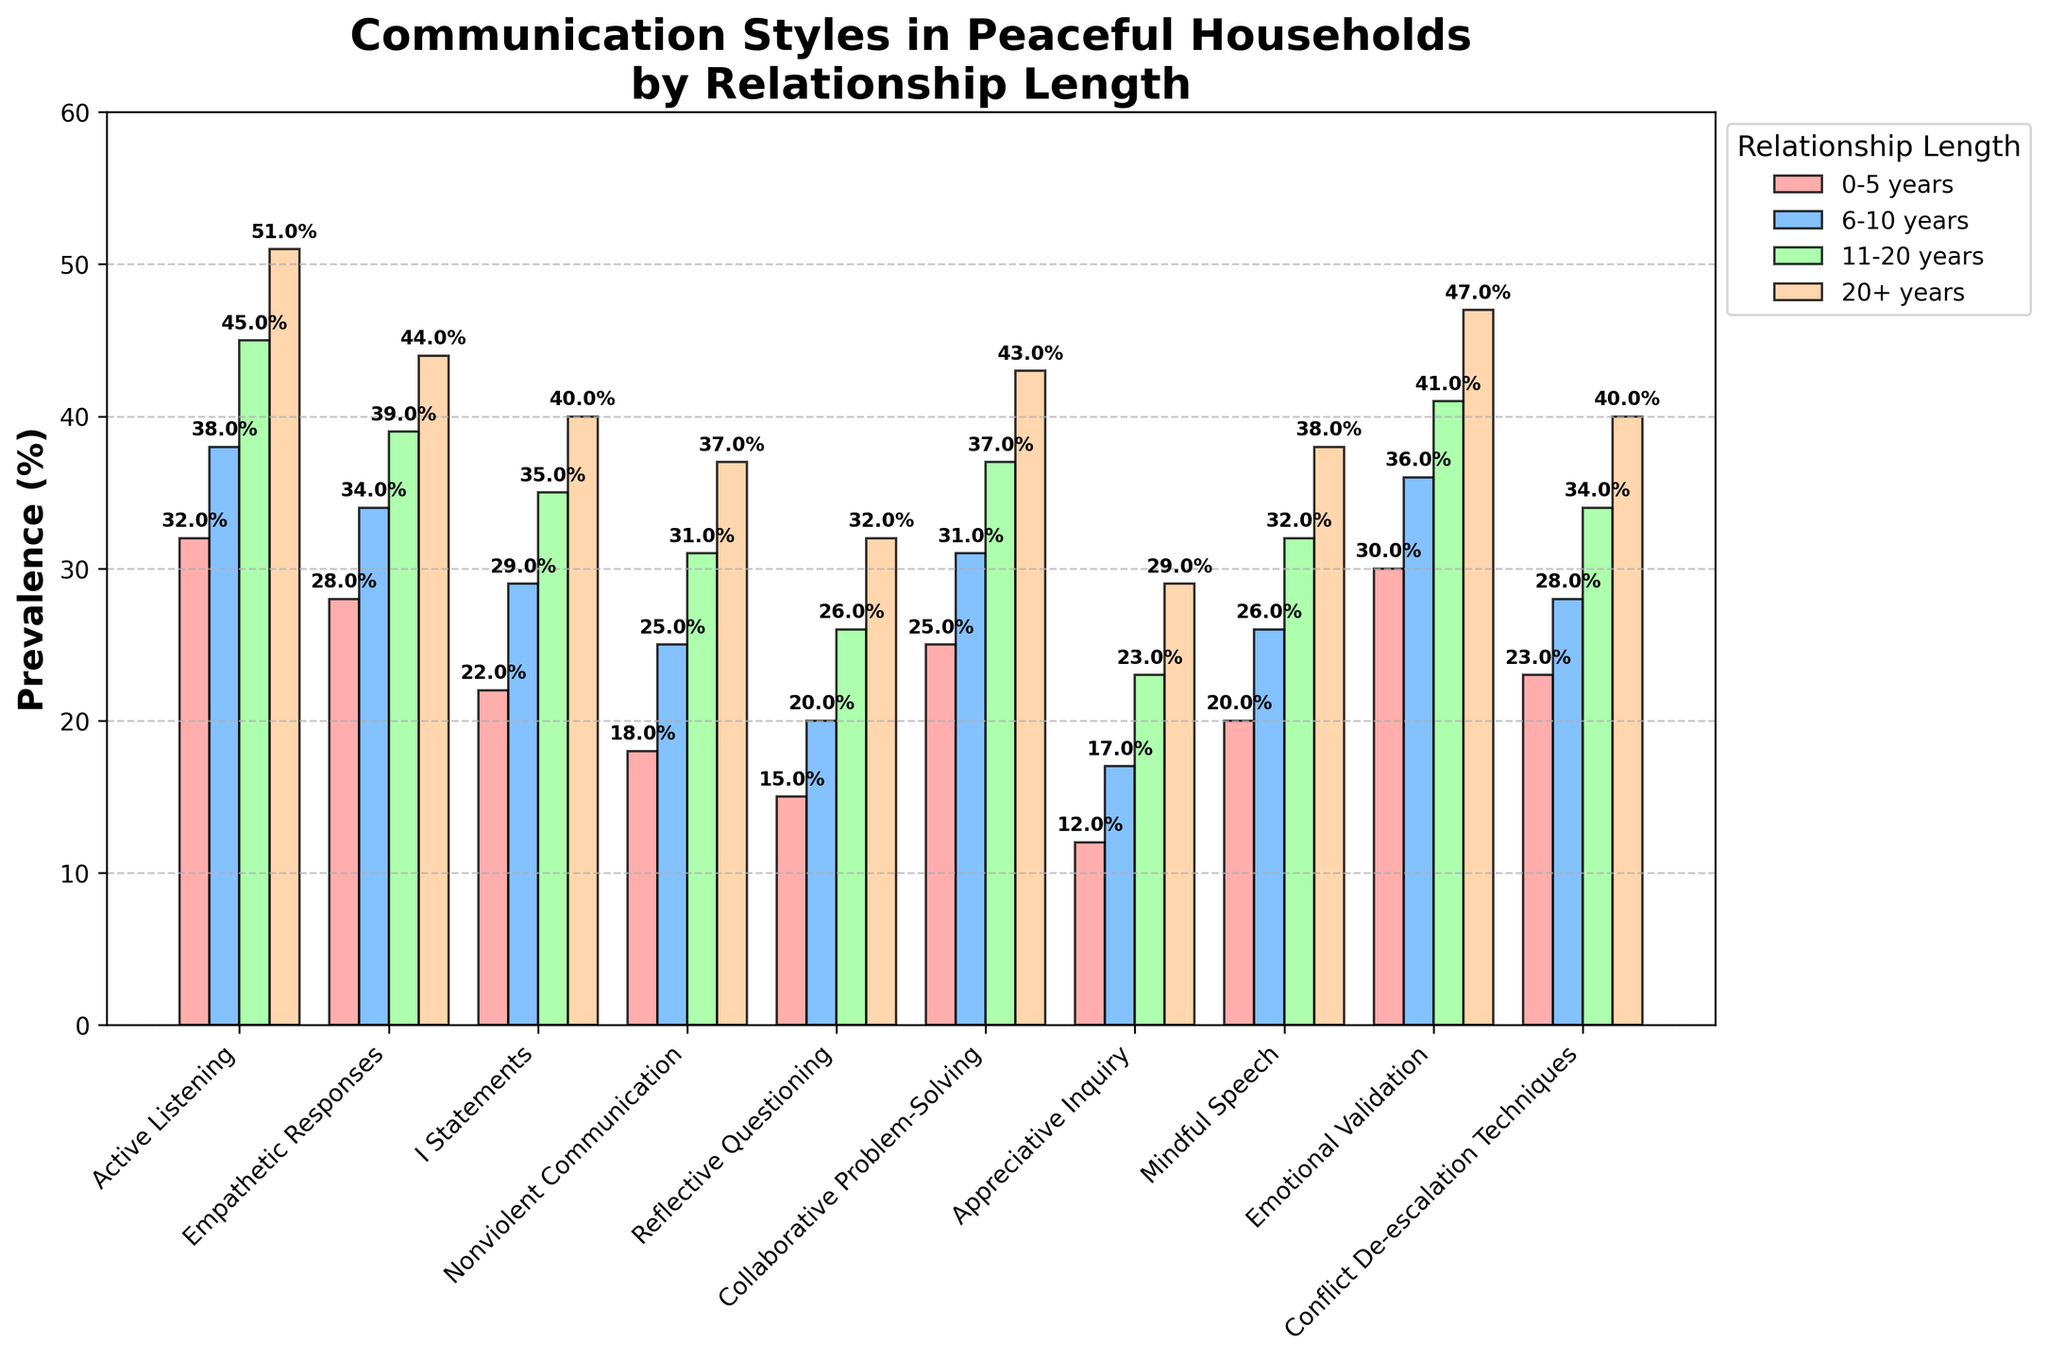What's the most prevalent communication style for relationships that last 20+ years? To determine the most prevalent communication style for relationships lasting over 20 years, we look at the heights of the bars for the 20+ years category. The bar representing "Active Listening" is the tallest one, indicating it has the highest prevalence.
Answer: Active Listening Which communication style shows the largest increase in prevalence from 0-5 years to 20+ years? Calculate the difference in prevalence percentage for each communication style between the 0-5 years and the 20+ years categories. The largest difference can be seen for "Active Listening" which increased from 32% to 51%.
Answer: Active Listening By how many percentage points does Empathetic Responses increase from 0-5 years to 20+ years? Subtract the prevalence percentage of "Empathetic Responses" in 0-5 years (28%) from that in 20+ years (44%). 44% - 28% equals 16 percentage points.
Answer: 16 percentage points Which communication style has the lowest prevalence in each relationship length category? Examine the shortest bars in each category. For 0-5 years, it is "Appreciative Inquiry" (12%); for 6-10 years, it is "Appreciative Inquiry" (17%); for 11-20 years, it is "Appreciative Inquiry" (23%); for 20+ years, it is "Appreciative Inquiry" (29%).
Answer: Appreciative Inquiry Do "Nonviolent Communication" and "Mindful Speech" have the same prevalence in any of the relationship length categories? Compare the prevalence values of "Nonviolent Communication" and "Mindful Speech" across all relationship length categories. They do not have matching prevalence values in any of the categories.
Answer: No Which has a greater increase in prevalence from 0-5 years to 6-10 years, "Conflict De-escalation Techniques" or "Collaborative Problem-Solving"? Subtract the 0-5 years prevalence from the 6-10 years prevalence for both styles: "Conflict De-escalation Techniques" increases from 23% to 28% (5 percentage points), while "Collaborative Problem-Solving" increases from 25% to 31% (6 percentage points).
Answer: Collaborative Problem-Solving In the 11-20 years category, which communication style is more prevalent: "Emotional Validation" or "Active Listening"? Compare the heights of the bars for "Emotional Validation" and "Active Listening" in the 11-20 years category. "Emotional Validation" is at 41%, whereas "Active Listening" is at 45%.
Answer: Active Listening What is the average prevalence of "I" Statements across all relationship lengths? Add the prevalence percentages of "I" Statements for all categories and divide by 4: (22% + 29% + 35% + 40%) / 4 equals 31.5%.
Answer: 31.5% Which communication style remains consistently below 40% prevalence across all relationship lengths? Look for the communication style that does not exceed 40% in any category. "Appreciative Inquiry" remains below 40% across all categories.
Answer: Appreciative Inquiry 